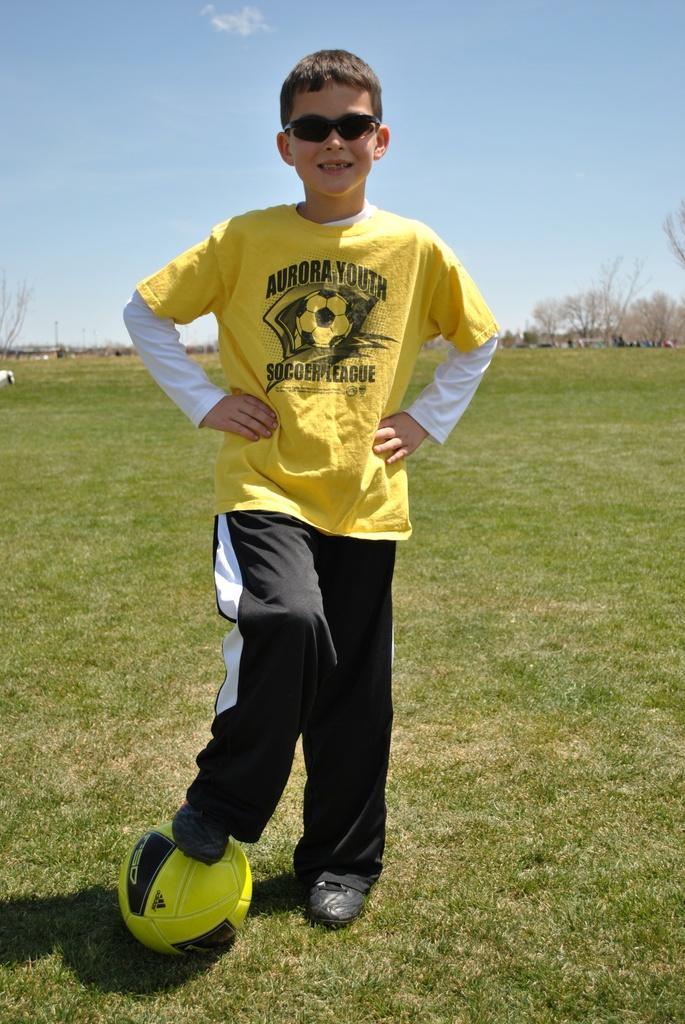Describe this image in one or two sentences. This picture is taken in the garden, There is a grass on the ground which is in green color, In the middle there is a boy standing and he is putting his right leg on the football which is in yellow color, In the background there is a blue color sky. 